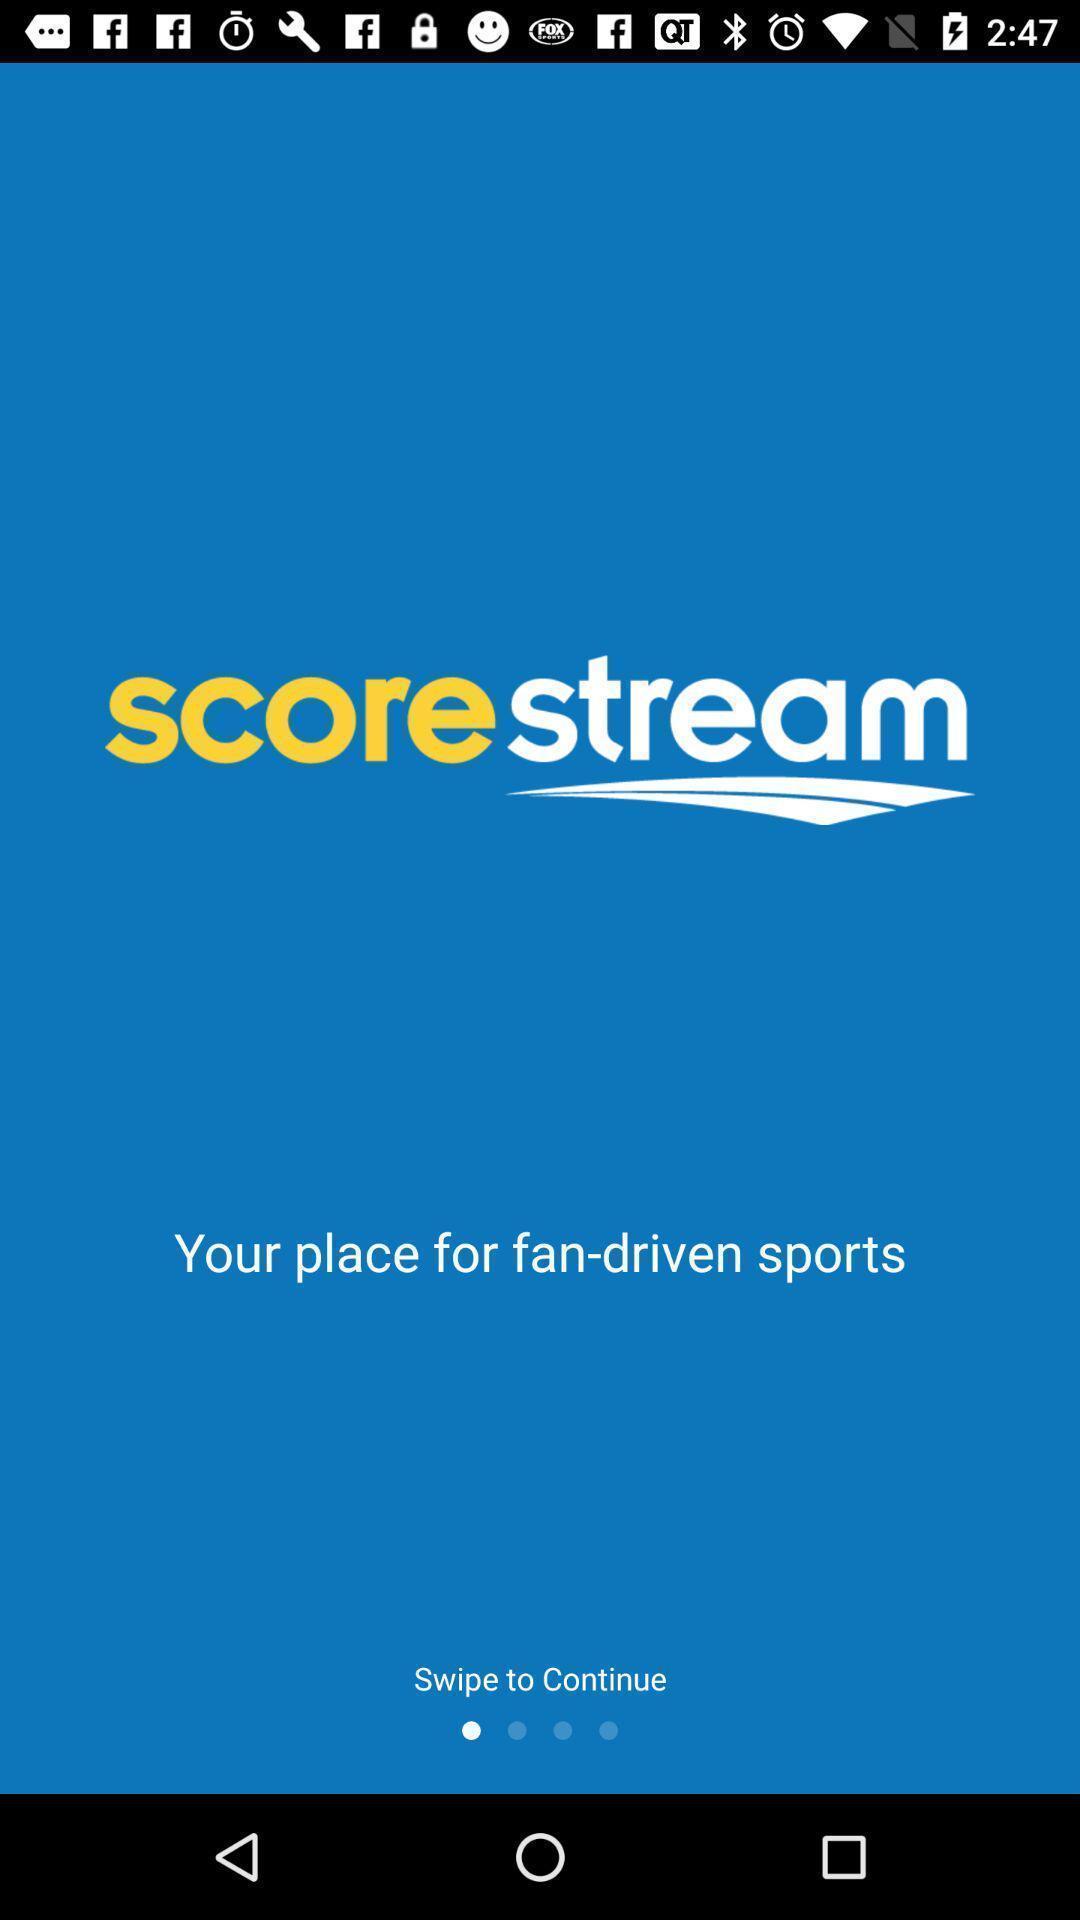What can you discern from this picture? Screen shows about sports app. 